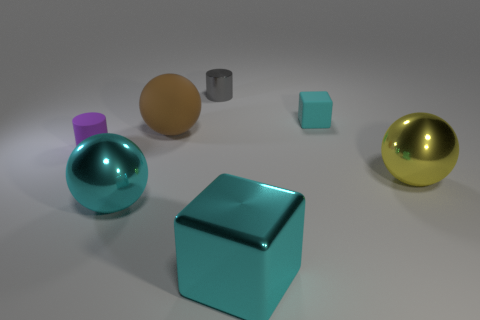There is another block that is the same color as the small block; what is its size?
Make the answer very short. Large. Do the tiny rubber cube and the shiny ball that is left of the tiny cyan block have the same color?
Provide a succinct answer. Yes. Is the number of big shiny cylinders greater than the number of small matte things?
Offer a very short reply. No. Are there any other things that are the same color as the tiny cube?
Provide a succinct answer. Yes. What number of other objects are there of the same size as the gray metal object?
Your response must be concise. 2. There is a cyan block that is right of the cyan thing in front of the big cyan shiny thing left of the large rubber thing; what is it made of?
Your answer should be very brief. Rubber. Is the brown sphere made of the same material as the small cylinder behind the tiny cyan cube?
Provide a succinct answer. No. Are there fewer big brown objects behind the matte ball than big cyan blocks right of the large cyan block?
Provide a succinct answer. No. How many small gray things have the same material as the cyan sphere?
Provide a short and direct response. 1. There is a cyan cube that is in front of the cylinder that is in front of the cyan rubber cube; is there a cyan metal object behind it?
Offer a terse response. Yes. 